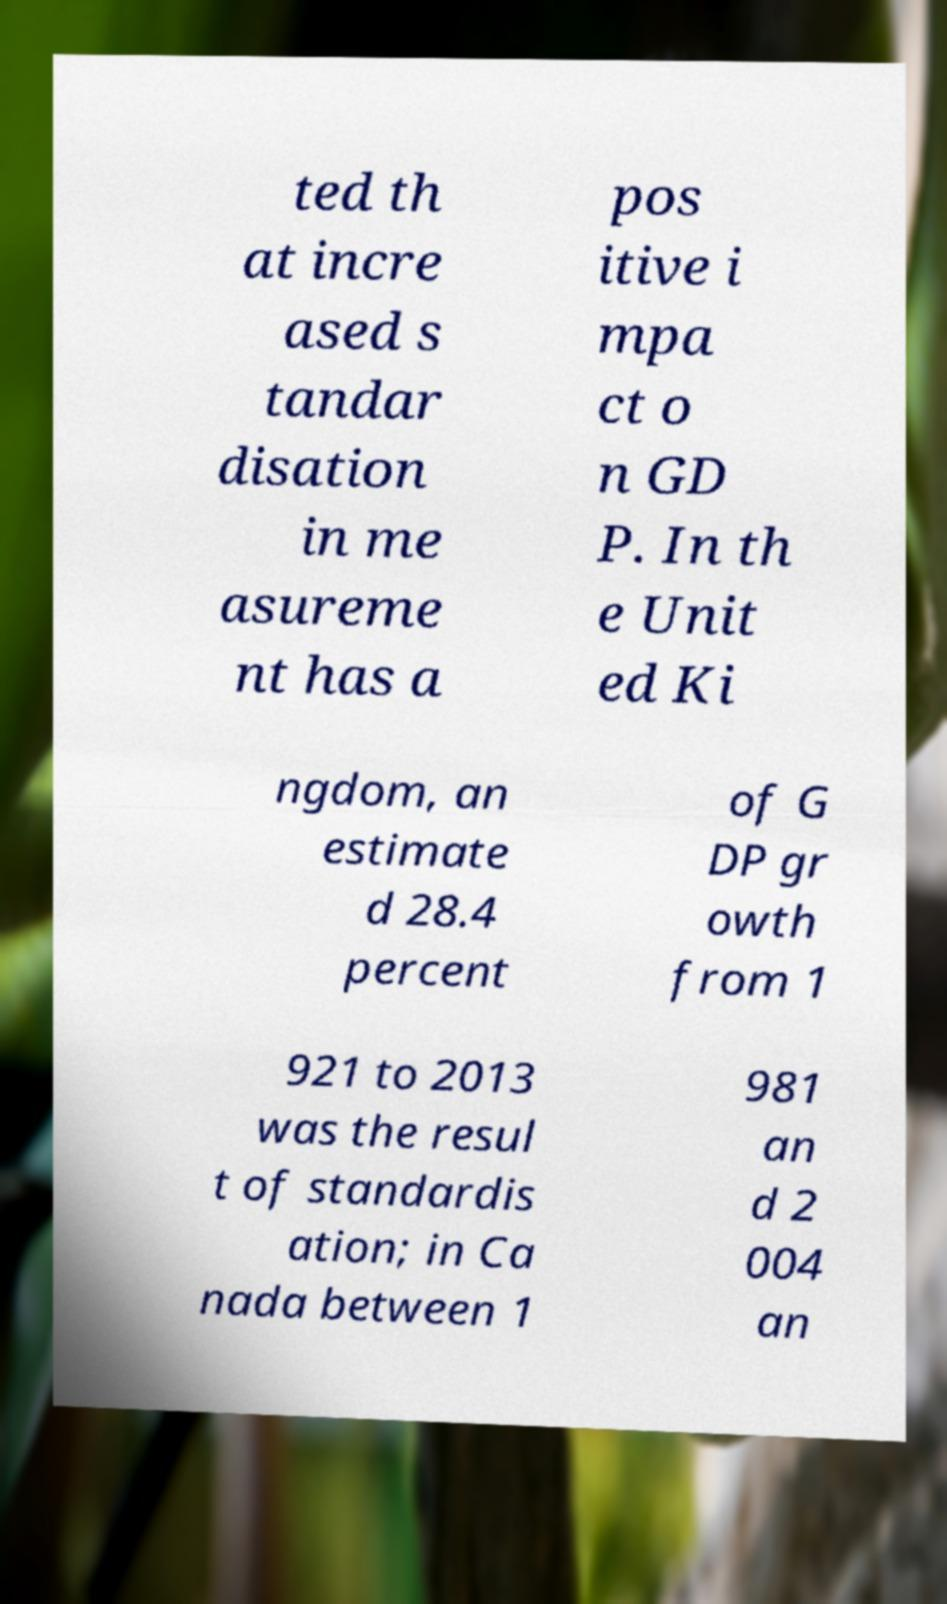Please identify and transcribe the text found in this image. ted th at incre ased s tandar disation in me asureme nt has a pos itive i mpa ct o n GD P. In th e Unit ed Ki ngdom, an estimate d 28.4 percent of G DP gr owth from 1 921 to 2013 was the resul t of standardis ation; in Ca nada between 1 981 an d 2 004 an 